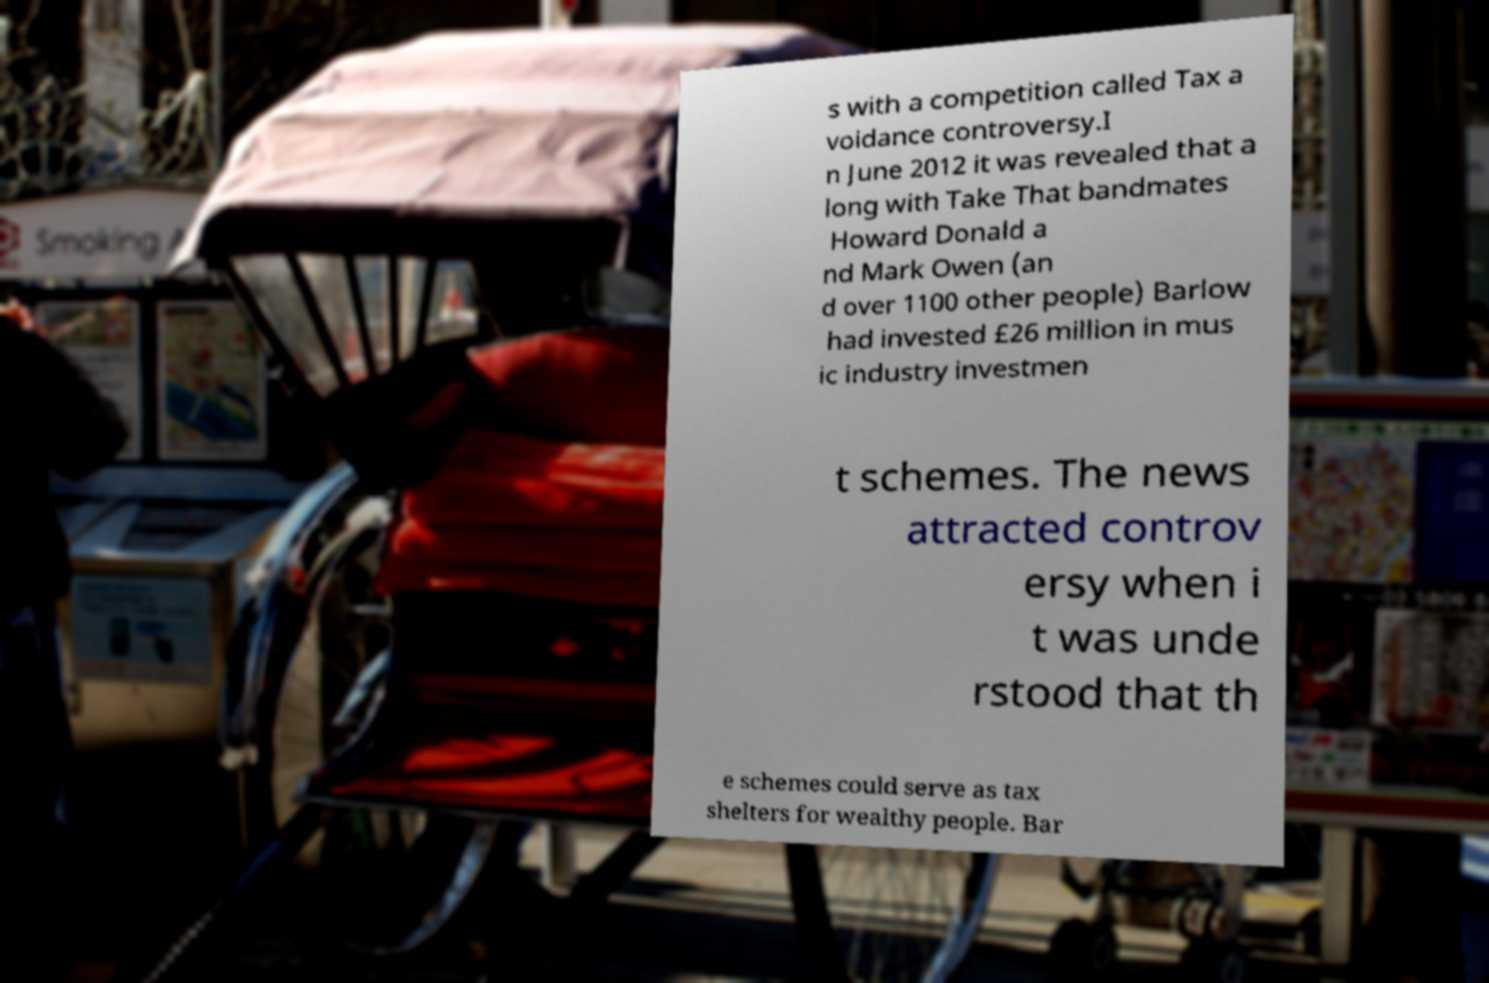Could you assist in decoding the text presented in this image and type it out clearly? s with a competition called Tax a voidance controversy.I n June 2012 it was revealed that a long with Take That bandmates Howard Donald a nd Mark Owen (an d over 1100 other people) Barlow had invested £26 million in mus ic industry investmen t schemes. The news attracted controv ersy when i t was unde rstood that th e schemes could serve as tax shelters for wealthy people. Bar 